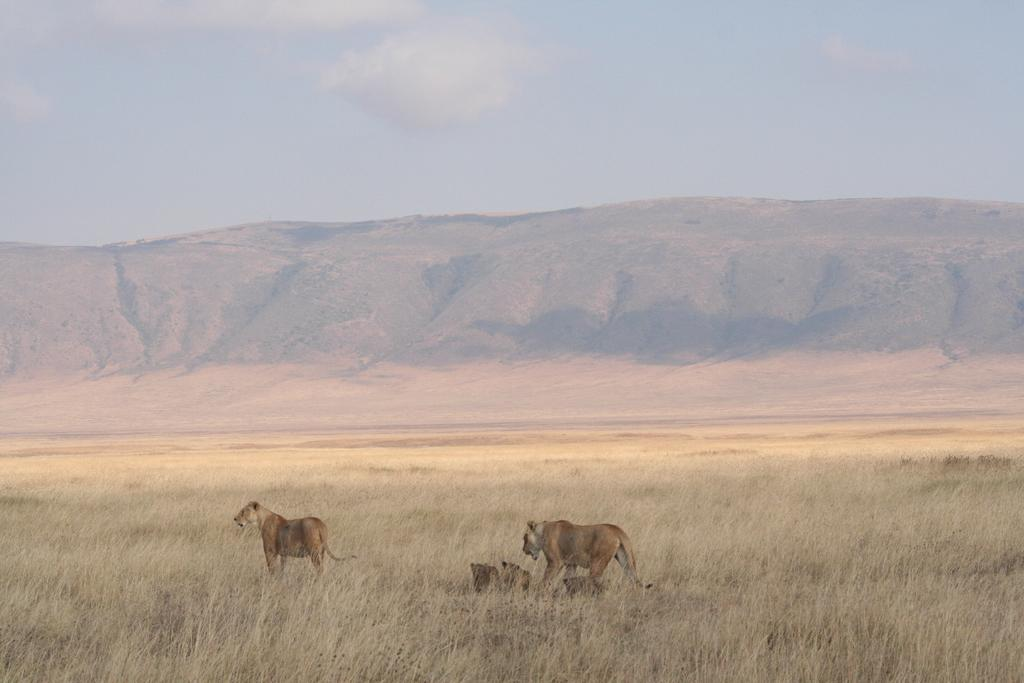What is located in the foreground of the image? There are animals in the foreground of the image. What is the environment in which the animals are situated? The animals are in the grass. What can be seen in the background of the image? There are hills in the background of the image. What is visible at the top of the image? The sky is visible at the top of the image. Where can you find the ticket booth for the concert stage in the image? There is no ticket booth or concert stage present in the image. What type of patch is visible on the animals' fur in the image? There are no patches visible on the animals' fur in the image. 